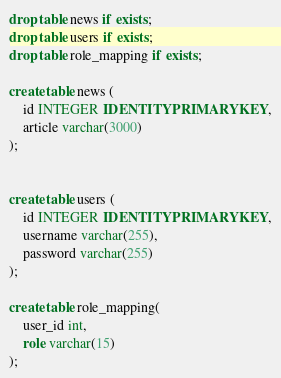<code> <loc_0><loc_0><loc_500><loc_500><_SQL_>drop table news if exists;
drop table users if exists;
drop table role_mapping if exists;

create table news (
	id INTEGER IDENTITY PRIMARY KEY,
	article varchar(3000)
);


create table users (
	id INTEGER IDENTITY PRIMARY KEY,
	username varchar(255),
	password varchar(255)
);

create table role_mapping(
	user_id int,
	role varchar(15)
);
</code> 